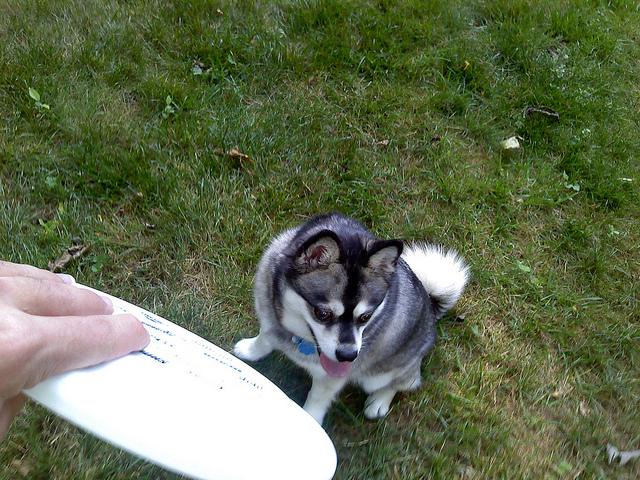What breed is the dog?
Write a very short answer. Husky. If the dog sees the disk will he know what comes next?
Keep it brief. Yes. What type of activity is the dog most likely waiting to participating in?
Quick response, please. Frisbee. 